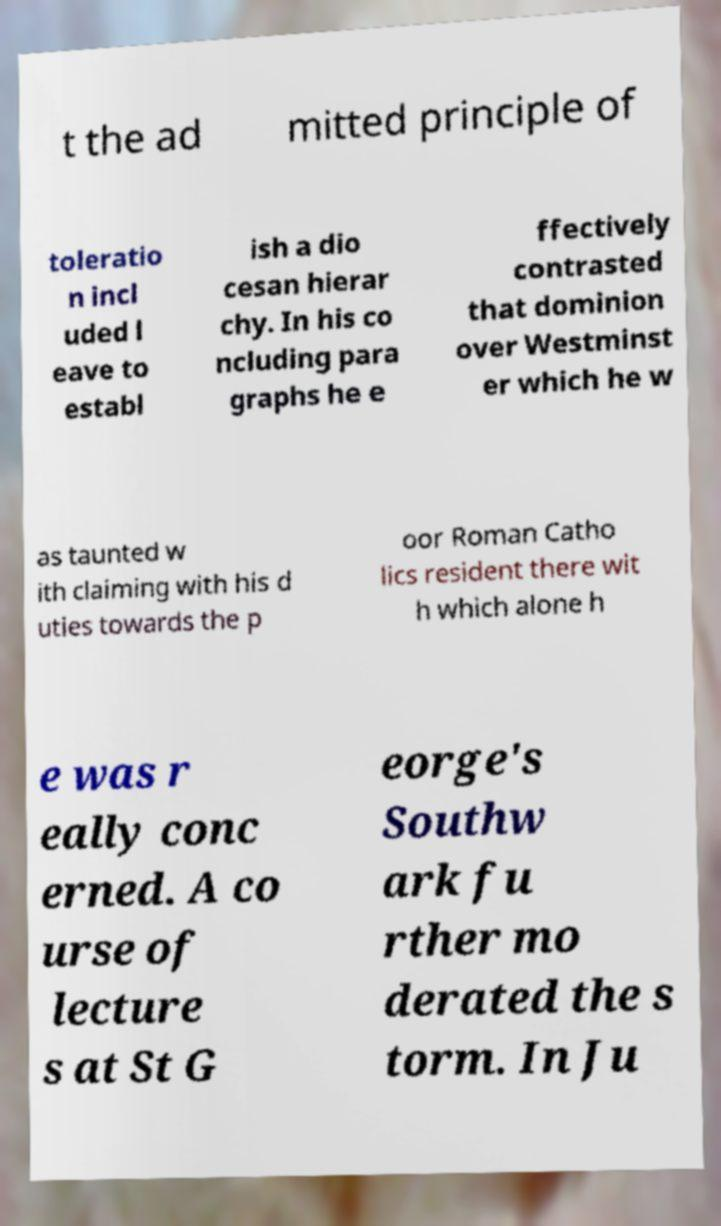Can you accurately transcribe the text from the provided image for me? t the ad mitted principle of toleratio n incl uded l eave to establ ish a dio cesan hierar chy. In his co ncluding para graphs he e ffectively contrasted that dominion over Westminst er which he w as taunted w ith claiming with his d uties towards the p oor Roman Catho lics resident there wit h which alone h e was r eally conc erned. A co urse of lecture s at St G eorge's Southw ark fu rther mo derated the s torm. In Ju 